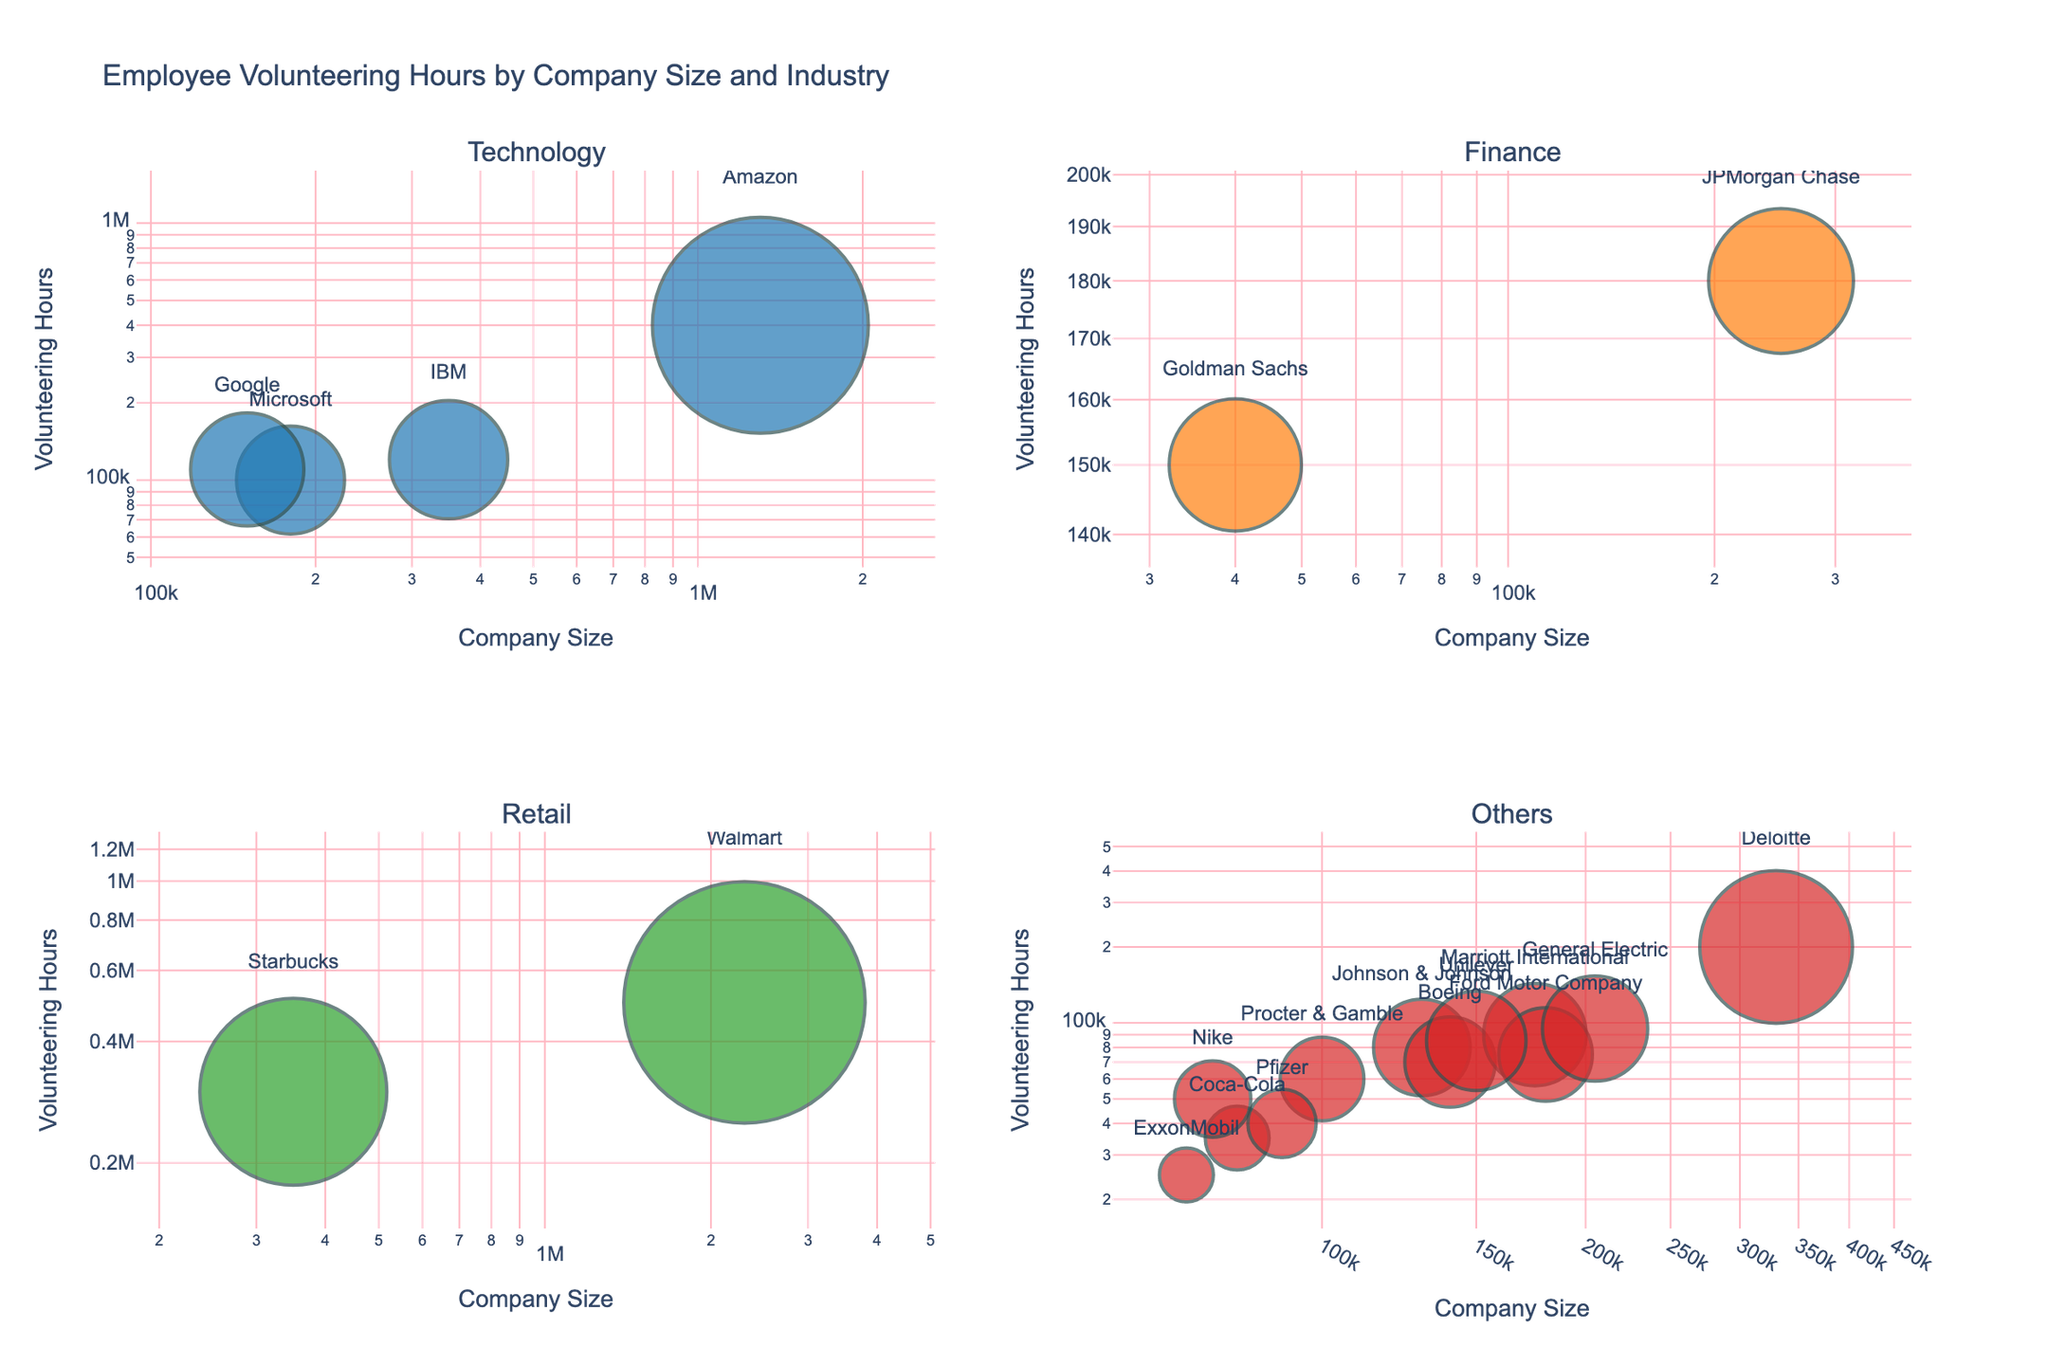What's the title of the plot? The title is located at the top of the figure. It reads "Objects in 'I Spy' Books: Size, Shape, and Frequency".
Answer: Objects in 'I Spy' Books: Size, Shape, and Frequency What color are the bubbles representing 'Teddy Bear'? To find the color, look at the 'Teddy Bear' bubbles, which are in the "Easy" category. Their color is light green.
Answer: Light green Which object in the 'Hard' difficulty level has the highest shape complexity? In the 'Hard' level subplot, locate the object with the highest shape complexity value. This is the 'Toy Robot' with a shape complexity of 4.
Answer: Toy Robot How many data points are there in the 'Medium' difficulty level? Count the number of bubbles in the 'Medium' level subplot. There are three data points.
Answer: 3 What is the size and shape complexity of the 'Kaleidoscope' in the 'Expert' level? Find the 'Kaleidoscope' bubble in the 'Expert' level subplot. Its size is 3, and its shape complexity is 5.
Answer: Size: 3, Shape Complexity: 5 Which difficulty level has the highest frequency object, and what is it? Locate the largest bubble across all subplots since frequency is directly proportional to bubble size. The highest frequency object is 'Lego Brick' in the 'Hard' difficulty level with a frequency of 10.
Answer: Hard, Lego Brick Which two objects have the same size and shape complexity in any subplot? Identify objects with matching size and shape complexity values across subplots. 'Apple' and 'Crayon' both have size 2 and shape complexity 1.
Answer: Apple and Crayon 